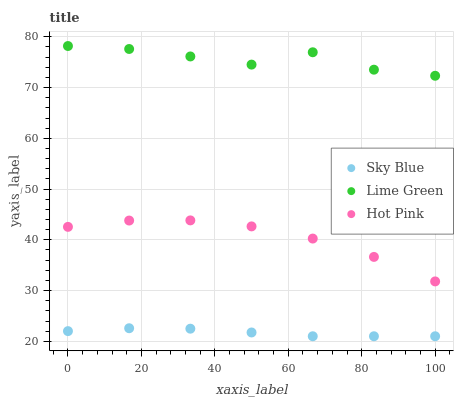Does Sky Blue have the minimum area under the curve?
Answer yes or no. Yes. Does Lime Green have the maximum area under the curve?
Answer yes or no. Yes. Does Hot Pink have the minimum area under the curve?
Answer yes or no. No. Does Hot Pink have the maximum area under the curve?
Answer yes or no. No. Is Sky Blue the smoothest?
Answer yes or no. Yes. Is Lime Green the roughest?
Answer yes or no. Yes. Is Hot Pink the smoothest?
Answer yes or no. No. Is Hot Pink the roughest?
Answer yes or no. No. Does Sky Blue have the lowest value?
Answer yes or no. Yes. Does Hot Pink have the lowest value?
Answer yes or no. No. Does Lime Green have the highest value?
Answer yes or no. Yes. Does Hot Pink have the highest value?
Answer yes or no. No. Is Sky Blue less than Lime Green?
Answer yes or no. Yes. Is Hot Pink greater than Sky Blue?
Answer yes or no. Yes. Does Sky Blue intersect Lime Green?
Answer yes or no. No. 